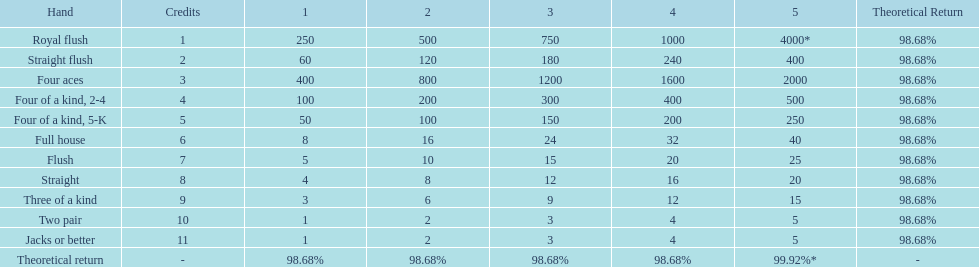What is the difference of payout on 3 credits, between a straight flush and royal flush? 570. 